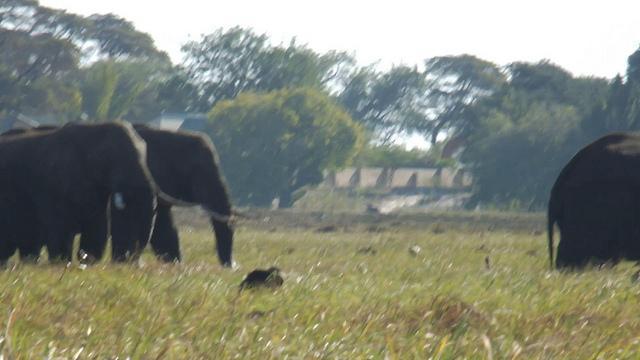How many elephants are there?
Give a very brief answer. 3. How many elephants can be seen?
Give a very brief answer. 3. 